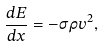<formula> <loc_0><loc_0><loc_500><loc_500>\frac { d E } { d x } = - \sigma \rho v ^ { 2 } ,</formula> 